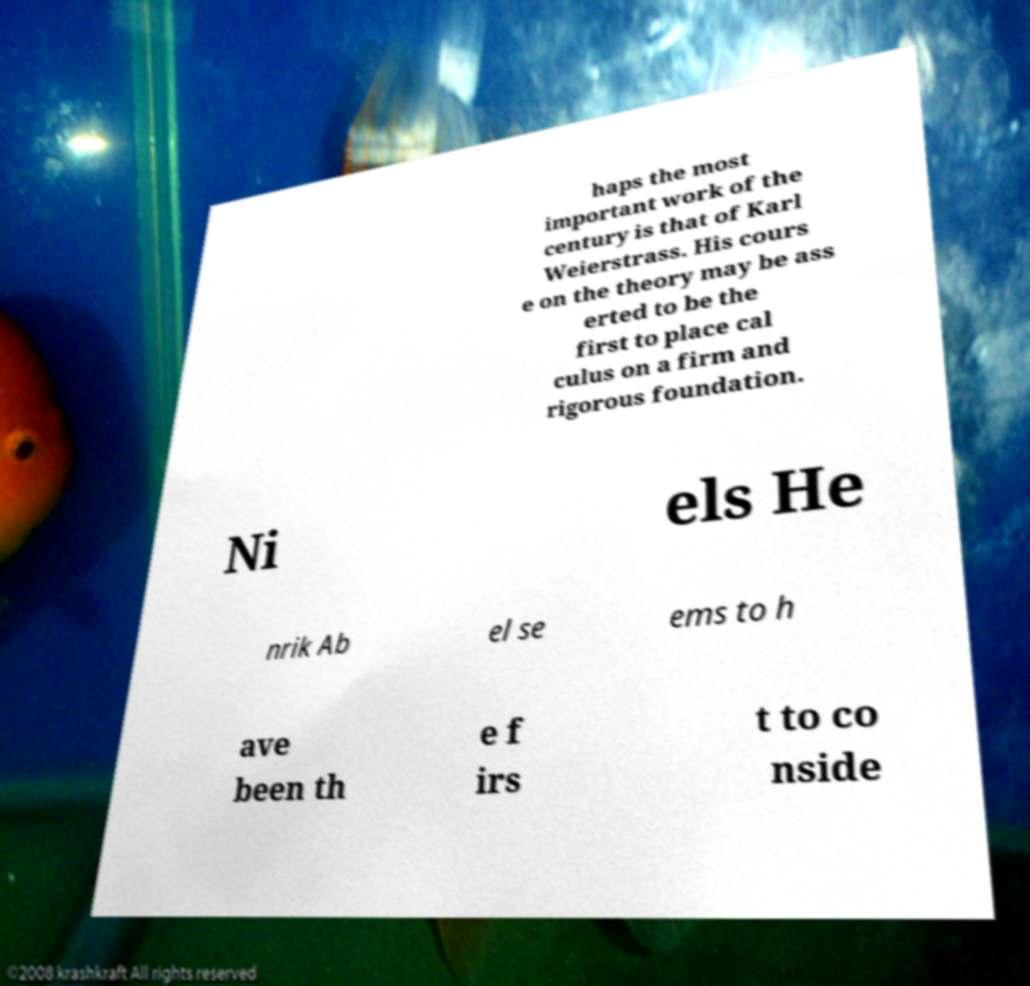Could you assist in decoding the text presented in this image and type it out clearly? haps the most important work of the century is that of Karl Weierstrass. His cours e on the theory may be ass erted to be the first to place cal culus on a firm and rigorous foundation. Ni els He nrik Ab el se ems to h ave been th e f irs t to co nside 